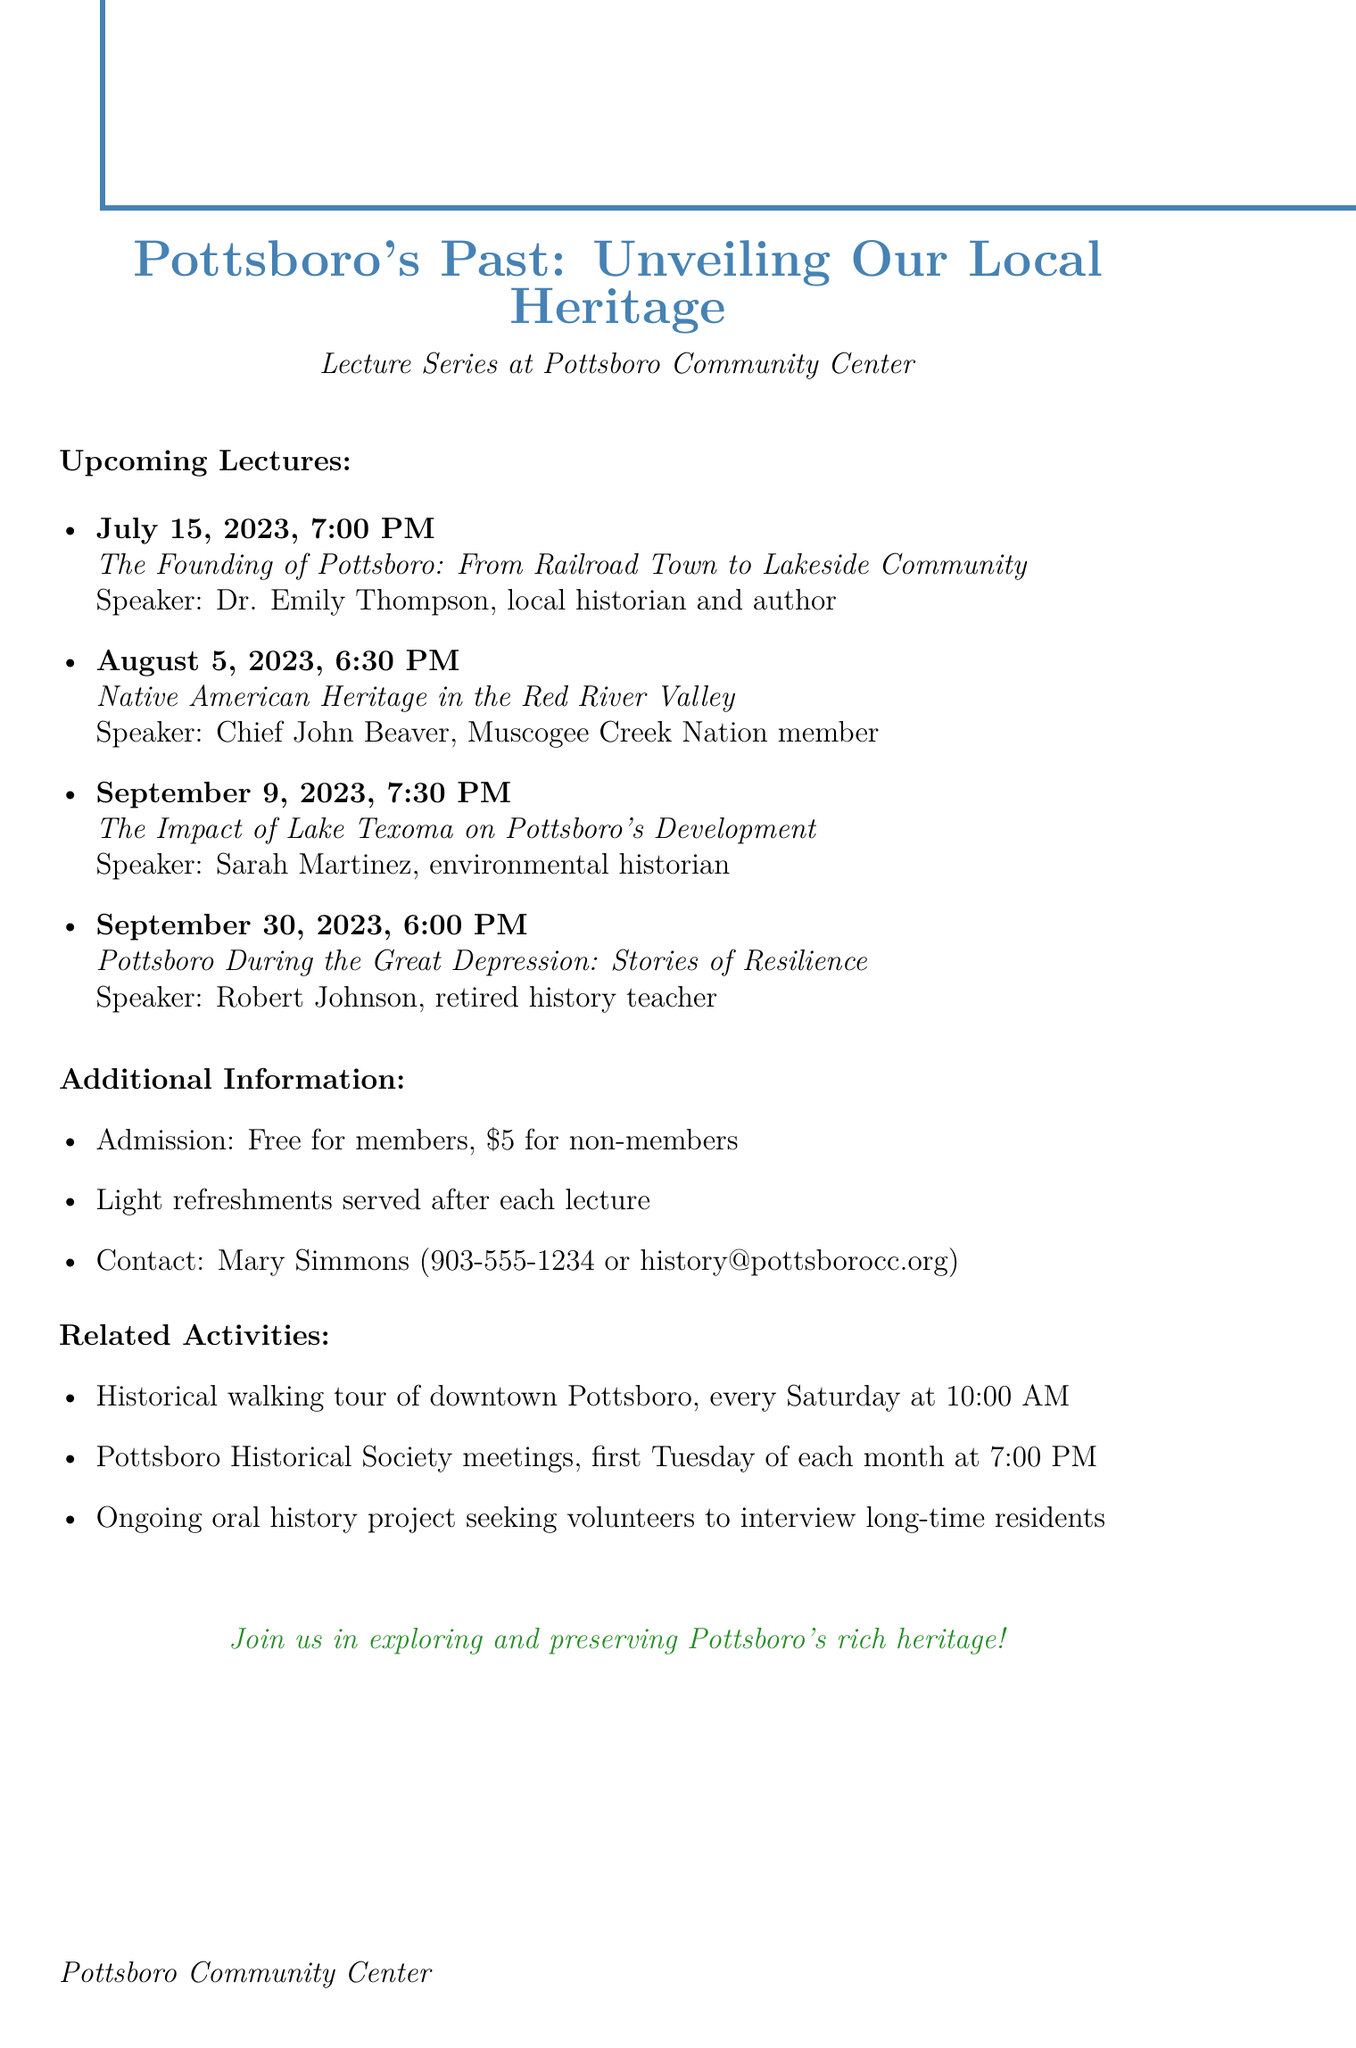What is the title of the lecture series? The title is explicitly mentioned at the beginning of the document under the lecture series title.
Answer: Pottsboro's Past: Unveiling Our Local Heritage Who is the speaker for the lecture on Native American Heritage? The lecture on Native American Heritage lists Chief John Beaver as the speaker.
Answer: Chief John Beaver What date is the lecture on the Founding of Pottsboro scheduled? The document provides specific dates for each upcoming lecture.
Answer: July 15, 2023 How much is the admission fee for non-members? The admission fees are outlined under additional information in the document.
Answer: $5 What are the light refreshments served after each lecture? The section on additional information mentions the refreshments provided after lectures but does not specify what they are, indicating they are light.
Answer: Light refreshments How long has Dr. Emily Thompson been researching Grayson County's history? This information is included in Dr. Thompson's bio, which mentions her years of research experience.
Answer: Over 20 years What is the time of the lecture on the impact of Lake Texoma? The time is clearly stated alongside the date and title of the lecture in the upcoming lectures list.
Answer: 7:30 PM When do the Pottsboro Historical Society meetings occur? The document specifies the schedule for the Pottsboro Historical Society meetings under related activities.
Answer: First Tuesday of each month at 7:00 PM What is the main focus of Sarah Martinez's research? This is mentioned in Sarah Martinez's bio, detailing her area of specialization.
Answer: Human-environment interactions in rural Texas communities 